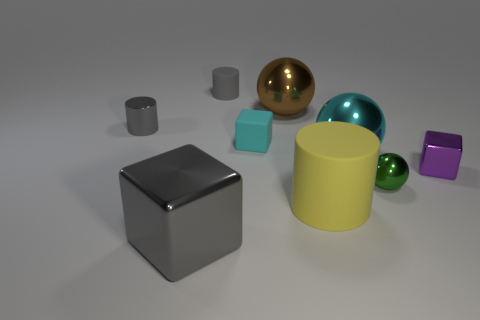Add 1 things. How many objects exist? 10 Subtract all spheres. How many objects are left? 6 Subtract 0 red spheres. How many objects are left? 9 Subtract all green spheres. Subtract all cyan blocks. How many objects are left? 7 Add 7 small metal cylinders. How many small metal cylinders are left? 8 Add 7 large gray metal cubes. How many large gray metal cubes exist? 8 